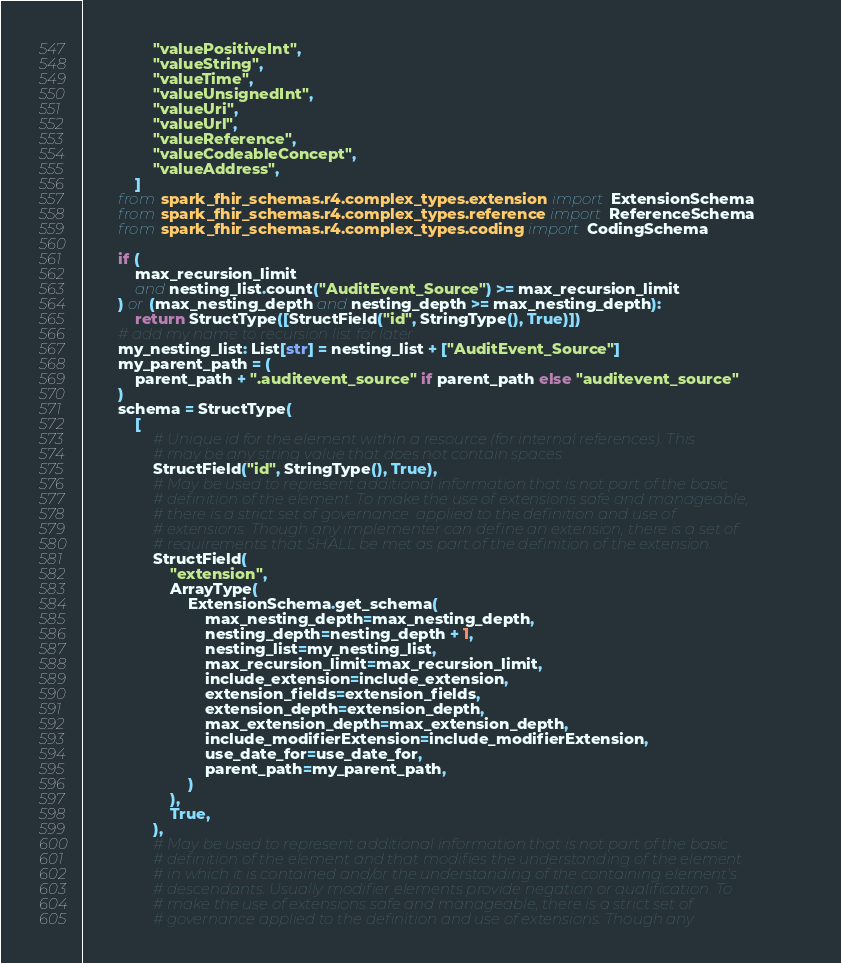Convert code to text. <code><loc_0><loc_0><loc_500><loc_500><_Python_>                "valuePositiveInt",
                "valueString",
                "valueTime",
                "valueUnsignedInt",
                "valueUri",
                "valueUrl",
                "valueReference",
                "valueCodeableConcept",
                "valueAddress",
            ]
        from spark_fhir_schemas.r4.complex_types.extension import ExtensionSchema
        from spark_fhir_schemas.r4.complex_types.reference import ReferenceSchema
        from spark_fhir_schemas.r4.complex_types.coding import CodingSchema

        if (
            max_recursion_limit
            and nesting_list.count("AuditEvent_Source") >= max_recursion_limit
        ) or (max_nesting_depth and nesting_depth >= max_nesting_depth):
            return StructType([StructField("id", StringType(), True)])
        # add my name to recursion list for later
        my_nesting_list: List[str] = nesting_list + ["AuditEvent_Source"]
        my_parent_path = (
            parent_path + ".auditevent_source" if parent_path else "auditevent_source"
        )
        schema = StructType(
            [
                # Unique id for the element within a resource (for internal references). This
                # may be any string value that does not contain spaces.
                StructField("id", StringType(), True),
                # May be used to represent additional information that is not part of the basic
                # definition of the element. To make the use of extensions safe and manageable,
                # there is a strict set of governance  applied to the definition and use of
                # extensions. Though any implementer can define an extension, there is a set of
                # requirements that SHALL be met as part of the definition of the extension.
                StructField(
                    "extension",
                    ArrayType(
                        ExtensionSchema.get_schema(
                            max_nesting_depth=max_nesting_depth,
                            nesting_depth=nesting_depth + 1,
                            nesting_list=my_nesting_list,
                            max_recursion_limit=max_recursion_limit,
                            include_extension=include_extension,
                            extension_fields=extension_fields,
                            extension_depth=extension_depth,
                            max_extension_depth=max_extension_depth,
                            include_modifierExtension=include_modifierExtension,
                            use_date_for=use_date_for,
                            parent_path=my_parent_path,
                        )
                    ),
                    True,
                ),
                # May be used to represent additional information that is not part of the basic
                # definition of the element and that modifies the understanding of the element
                # in which it is contained and/or the understanding of the containing element's
                # descendants. Usually modifier elements provide negation or qualification. To
                # make the use of extensions safe and manageable, there is a strict set of
                # governance applied to the definition and use of extensions. Though any</code> 